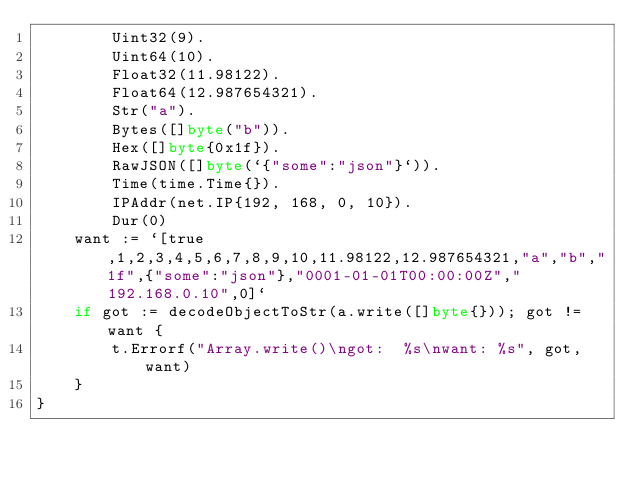Convert code to text. <code><loc_0><loc_0><loc_500><loc_500><_Go_>		Uint32(9).
		Uint64(10).
		Float32(11.98122).
		Float64(12.987654321).
		Str("a").
		Bytes([]byte("b")).
		Hex([]byte{0x1f}).
		RawJSON([]byte(`{"some":"json"}`)).
		Time(time.Time{}).
		IPAddr(net.IP{192, 168, 0, 10}).
		Dur(0)
	want := `[true,1,2,3,4,5,6,7,8,9,10,11.98122,12.987654321,"a","b","1f",{"some":"json"},"0001-01-01T00:00:00Z","192.168.0.10",0]`
	if got := decodeObjectToStr(a.write([]byte{})); got != want {
		t.Errorf("Array.write()\ngot:  %s\nwant: %s", got, want)
	}
}
</code> 